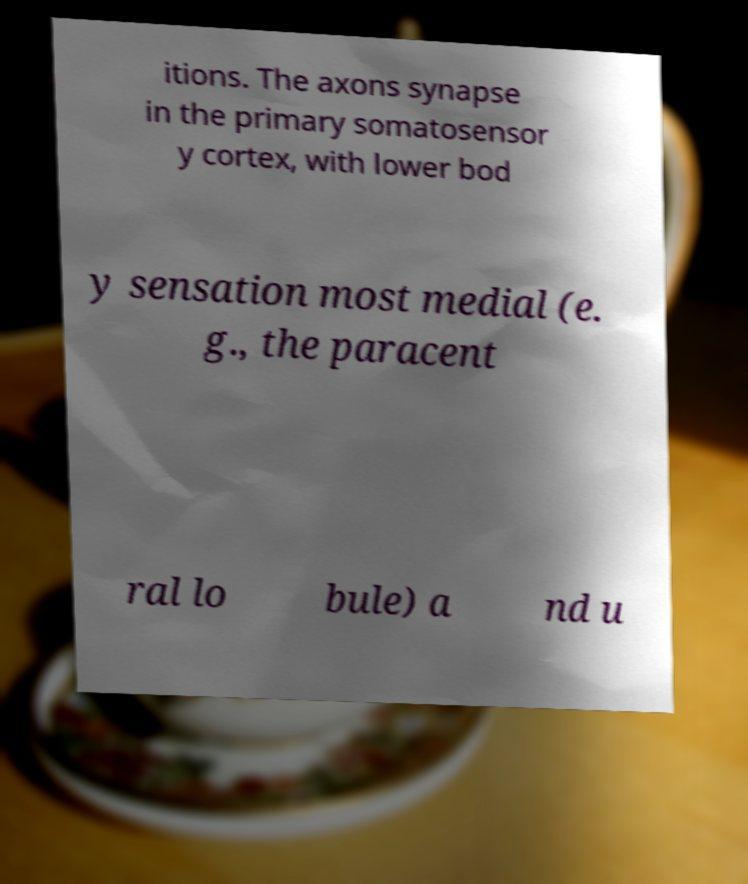There's text embedded in this image that I need extracted. Can you transcribe it verbatim? itions. The axons synapse in the primary somatosensor y cortex, with lower bod y sensation most medial (e. g., the paracent ral lo bule) a nd u 